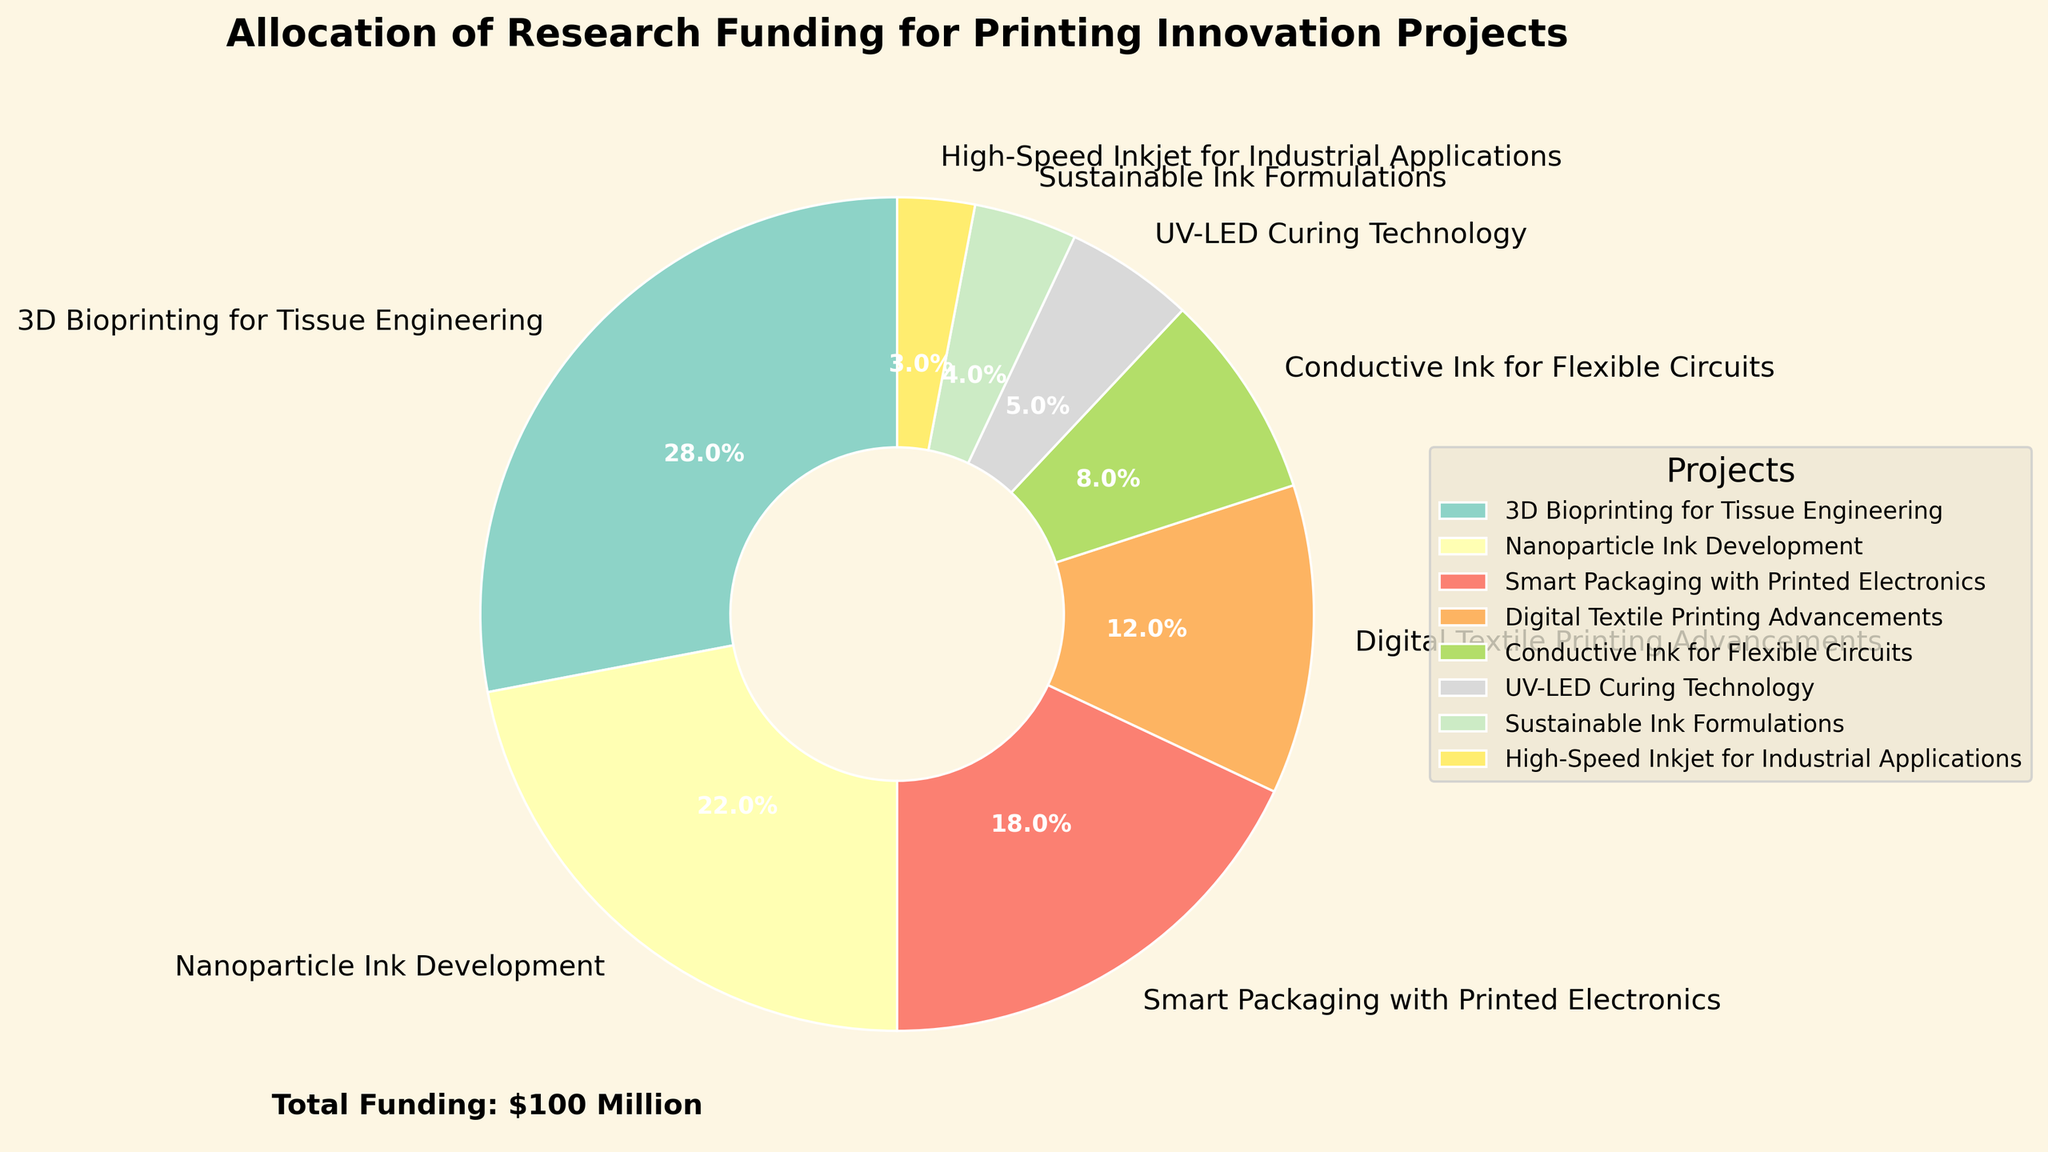What is the largest single allocation of research funding? The largest single allocation can be identified by finding the project with the largest percentage in the pie chart. The slice for "3D Bioprinting for Tissue Engineering" takes up the most space, representing 28%.
Answer: 3D Bioprinting for Tissue Engineering Which project received the least funding? To find the project with the least funding, look for the smallest slice in the pie chart. The slice for "High-Speed Inkjet for Industrial Applications" is the smallest at 3%.
Answer: High-Speed Inkjet for Industrial Applications What percentage of the funding is allocated to the top two projects combined? The top two projects based on the largest slices are "3D Bioprinting for Tissue Engineering" and "Nanoparticle Ink Development" with 28% and 22%, respectively. Adding these percentages: 28% + 22% = 50%.
Answer: 50% How much more funding was allocated to "Smart Packaging with Printed Electronics" compared to "Sustainable Ink Formulations"? Identify the funding allocations for both projects: "Smart Packaging with Printed Electronics" is at 18%, and "Sustainable Ink Formulations" is at 4%. Subtract the smaller percentage from the larger one: 18% - 4% = 14%.
Answer: 14% Which project has almost half the funding allocation of "Digital Textile Printing Advancements"? The funding allocation for "Digital Textile Printing Advancements" is 12%. Half of 12% is 6%. The project closest to this value is "Conductive Ink for Flexible Circuits" at 8%.
Answer: Conductive Ink for Flexible Circuits What combined percentage of the funding is allocated to "Conductive Ink for Flexible Circuits," "UV-LED Curing Technology," and "Sustainable Ink Formulations"? Sum the percentages allocated to these three projects: 8% (Conductive Ink for Flexible Circuits) + 5% (UV-LED Curing Technology) + 4% (Sustainable Ink Formulations) = 17%.
Answer: 17% How does the funding allocation of "Nanoparticle Ink Development" compare to "3D Bioprinting for Tissue Engineering"? Compare their percentages: "Nanoparticle Ink Development" is allocated 22%, whereas "3D Bioprinting for Tissue Engineering" is allocated 28%. 28% is greater than 22%.
Answer: 3D Bioprinting for Tissue Engineering has more funding What is the difference in funding allocation between the project with the highest percentage and the project with the second-lowest percentage? The project with the highest percentage is "3D Bioprinting for Tissue Engineering" (28%), and the second-lowest percentage is "Sustainable Ink Formulations" (4%). The difference is 28% - 4% = 24%.
Answer: 24% What color is used to represent "High-Speed Inkjet for Industrial Applications"? Identify the slice color for "High-Speed Inkjet for Industrial Applications" by examining its visual attribute on the pie chart. This color is usually distinctly different from others for easy readability.
Answer: (Answer will depend on the actual color used in the plot) How much funding is allocated to "UV-LED Curing Technology" relative to the total funding? The total funding is $100 million. "UV-LED Curing Technology" is allocated 5%. To find the relative amount in dollars, calculate 5% of 100 million: 0.05 * 100,000,000 = 5,000,000 dollars.
Answer: 5 million dollars 